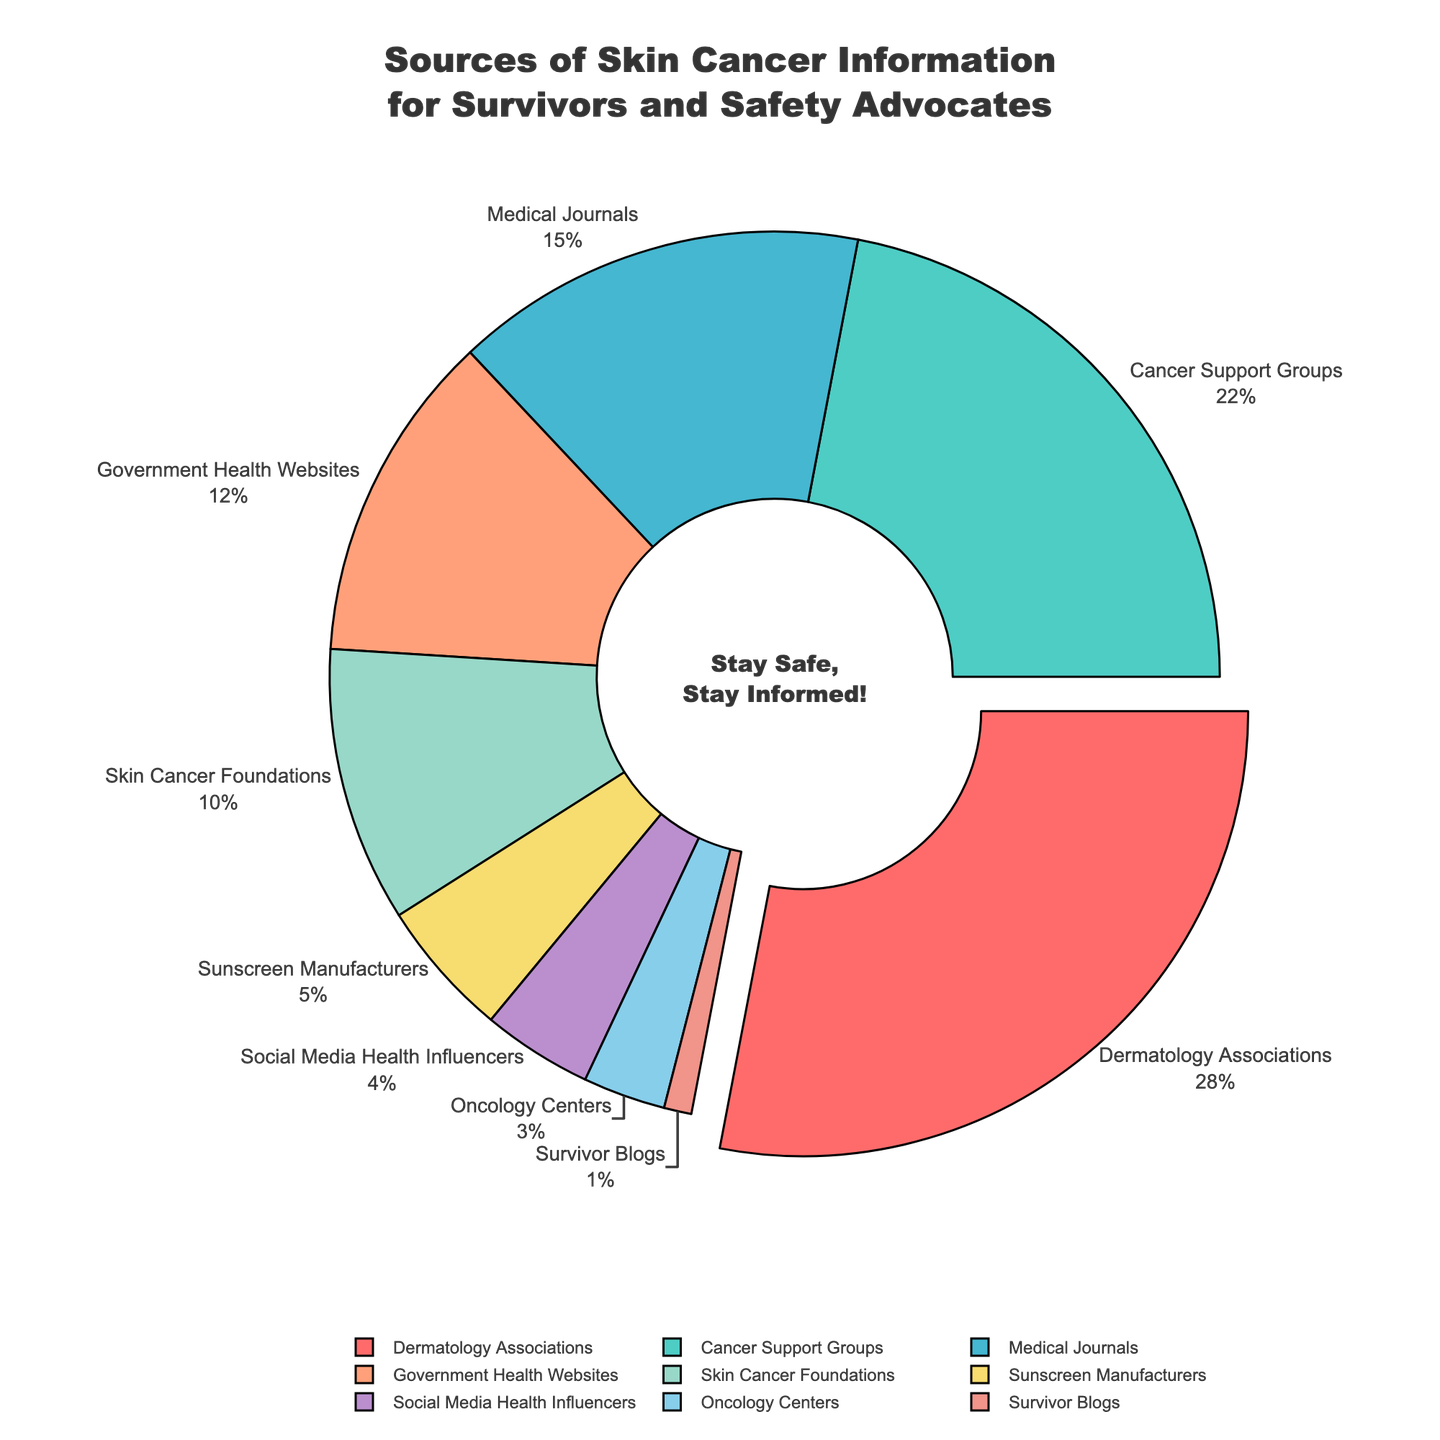What is the highest percentage source of skin cancer information? Checking the pie chart, the 'Dermatology Associations' section is the largest, indicating the highest percentage.
Answer: Dermatology Associations, 28% Compare the percentages of 'Cancer Support Groups' and 'Skin Cancer Foundations'. Which one is higher? The pie chart shows that 'Cancer Support Groups' have a percentage of 22%, while 'Skin Cancer Foundations' have 10%. Therefore, 'Cancer Support Groups' is higher.
Answer: Cancer Support Groups What is the total percentage of information sources related to professional medical institutions, including 'Dermatology Associations', 'Medical Journals', and 'Oncology Centers'? Summing the percentages of 'Dermatology Associations' (28%), 'Medical Journals' (15%), and 'Oncology Centers' (3%) gives 28 + 15 + 3 = 46.
Answer: 46% Which source is represented by the smallest segment in the pie chart? The smallest segment in the pie chart indicates 'Survivor Blogs' with a percentage of 1%.
Answer: Survivor Blogs Are there more information sources with a percentage higher than 10% or equal to or under 10%? Sources above 10%: 'Dermatology Associations' (28%), 'Cancer Support Groups' (22%), 'Medical Journals' (15%), and 'Government Health Websites' (12%). That's 4 sources. Sources 10% or below: 'Skin Cancer Foundations' (10%), 'Sunscreen Manufacturers' (5%), 'Social Media Health Influencers' (4%), 'Oncology Centers' (3%), and 'Survivor Blogs' (1%). That's 5 sources. 5 is greater than 4.
Answer: Equal to or under 10% What percentage of skin cancer information comes from non-medical professional sources (excluding 'Dermatology Associations', 'Medical Journals', and 'Oncology Centers')? Summing the percentages of the non-medical professional sources: 'Cancer Support Groups' (22%), 'Government Health Websites' (12%), 'Skin Cancer Foundations' (10%), 'Sunscreen Manufacturers' (5%), 'Social Media Health Influencers' (4%), and 'Survivor Blogs' (1%) gives 22 + 12 + 10 + 5 + 4 + 1 = 54.
Answer: 54% What is the visual cue used to highlight the largest percentage segment on the pie chart? The largest percentage segment, 'Dermatology Associations', is highlighted by being slightly pulled out from the rest of the pie segments.
Answer: Pulled out segment Add the percentages of ‘Sunscreen Manufacturers’ and ‘Social Media Health Influencers’. What value do you get? The percentages for 'Sunscreen Manufacturers' and 'Social Media Health Influencers' are 5% and 4% respectively. Adding them gives 5 + 4 = 9.
Answer: 9% Between 'Government Health Websites' and 'Oncology Centers', which has a lesser percentage? The pie chart shows 'Oncology Centers' with 3% and 'Government Health Websites' with 12%. Thus, 'Oncology Centers' has a lesser percentage.
Answer: Oncology Centers The combined percentage of ‘Medical Journals’ and ‘Survivor Blogs’ is closest to which single source? 'Medical Journals' is 15% and 'Survivor Blogs' is 1%. Their combined percentage is 15 + 1 = 16. The closest percentages in the pie chart are 'Medical Journals' (15%) and 'Government Health Websites' (12%).
Answer: Medical Journals 